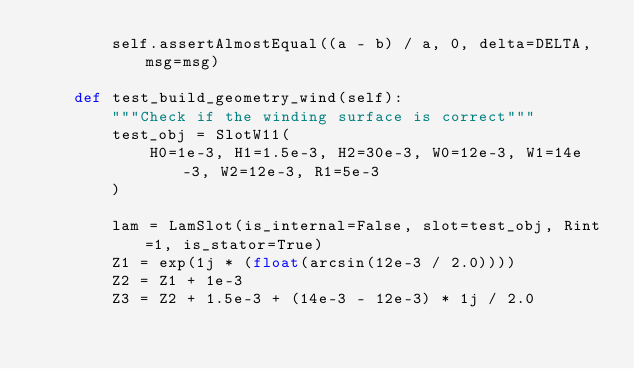Convert code to text. <code><loc_0><loc_0><loc_500><loc_500><_Python_>        self.assertAlmostEqual((a - b) / a, 0, delta=DELTA, msg=msg)

    def test_build_geometry_wind(self):
        """Check if the winding surface is correct"""
        test_obj = SlotW11(
            H0=1e-3, H1=1.5e-3, H2=30e-3, W0=12e-3, W1=14e-3, W2=12e-3, R1=5e-3
        )

        lam = LamSlot(is_internal=False, slot=test_obj, Rint=1, is_stator=True)
        Z1 = exp(1j * (float(arcsin(12e-3 / 2.0))))
        Z2 = Z1 + 1e-3
        Z3 = Z2 + 1.5e-3 + (14e-3 - 12e-3) * 1j / 2.0</code> 